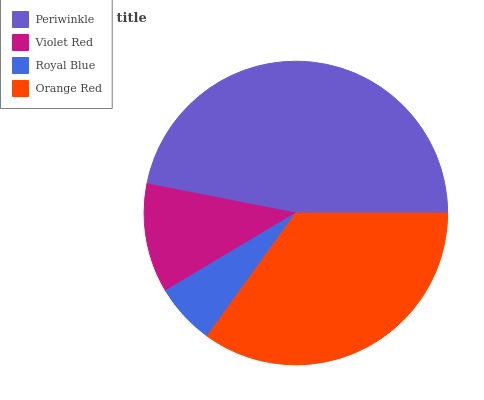Is Royal Blue the minimum?
Answer yes or no. Yes. Is Periwinkle the maximum?
Answer yes or no. Yes. Is Violet Red the minimum?
Answer yes or no. No. Is Violet Red the maximum?
Answer yes or no. No. Is Periwinkle greater than Violet Red?
Answer yes or no. Yes. Is Violet Red less than Periwinkle?
Answer yes or no. Yes. Is Violet Red greater than Periwinkle?
Answer yes or no. No. Is Periwinkle less than Violet Red?
Answer yes or no. No. Is Orange Red the high median?
Answer yes or no. Yes. Is Violet Red the low median?
Answer yes or no. Yes. Is Periwinkle the high median?
Answer yes or no. No. Is Royal Blue the low median?
Answer yes or no. No. 